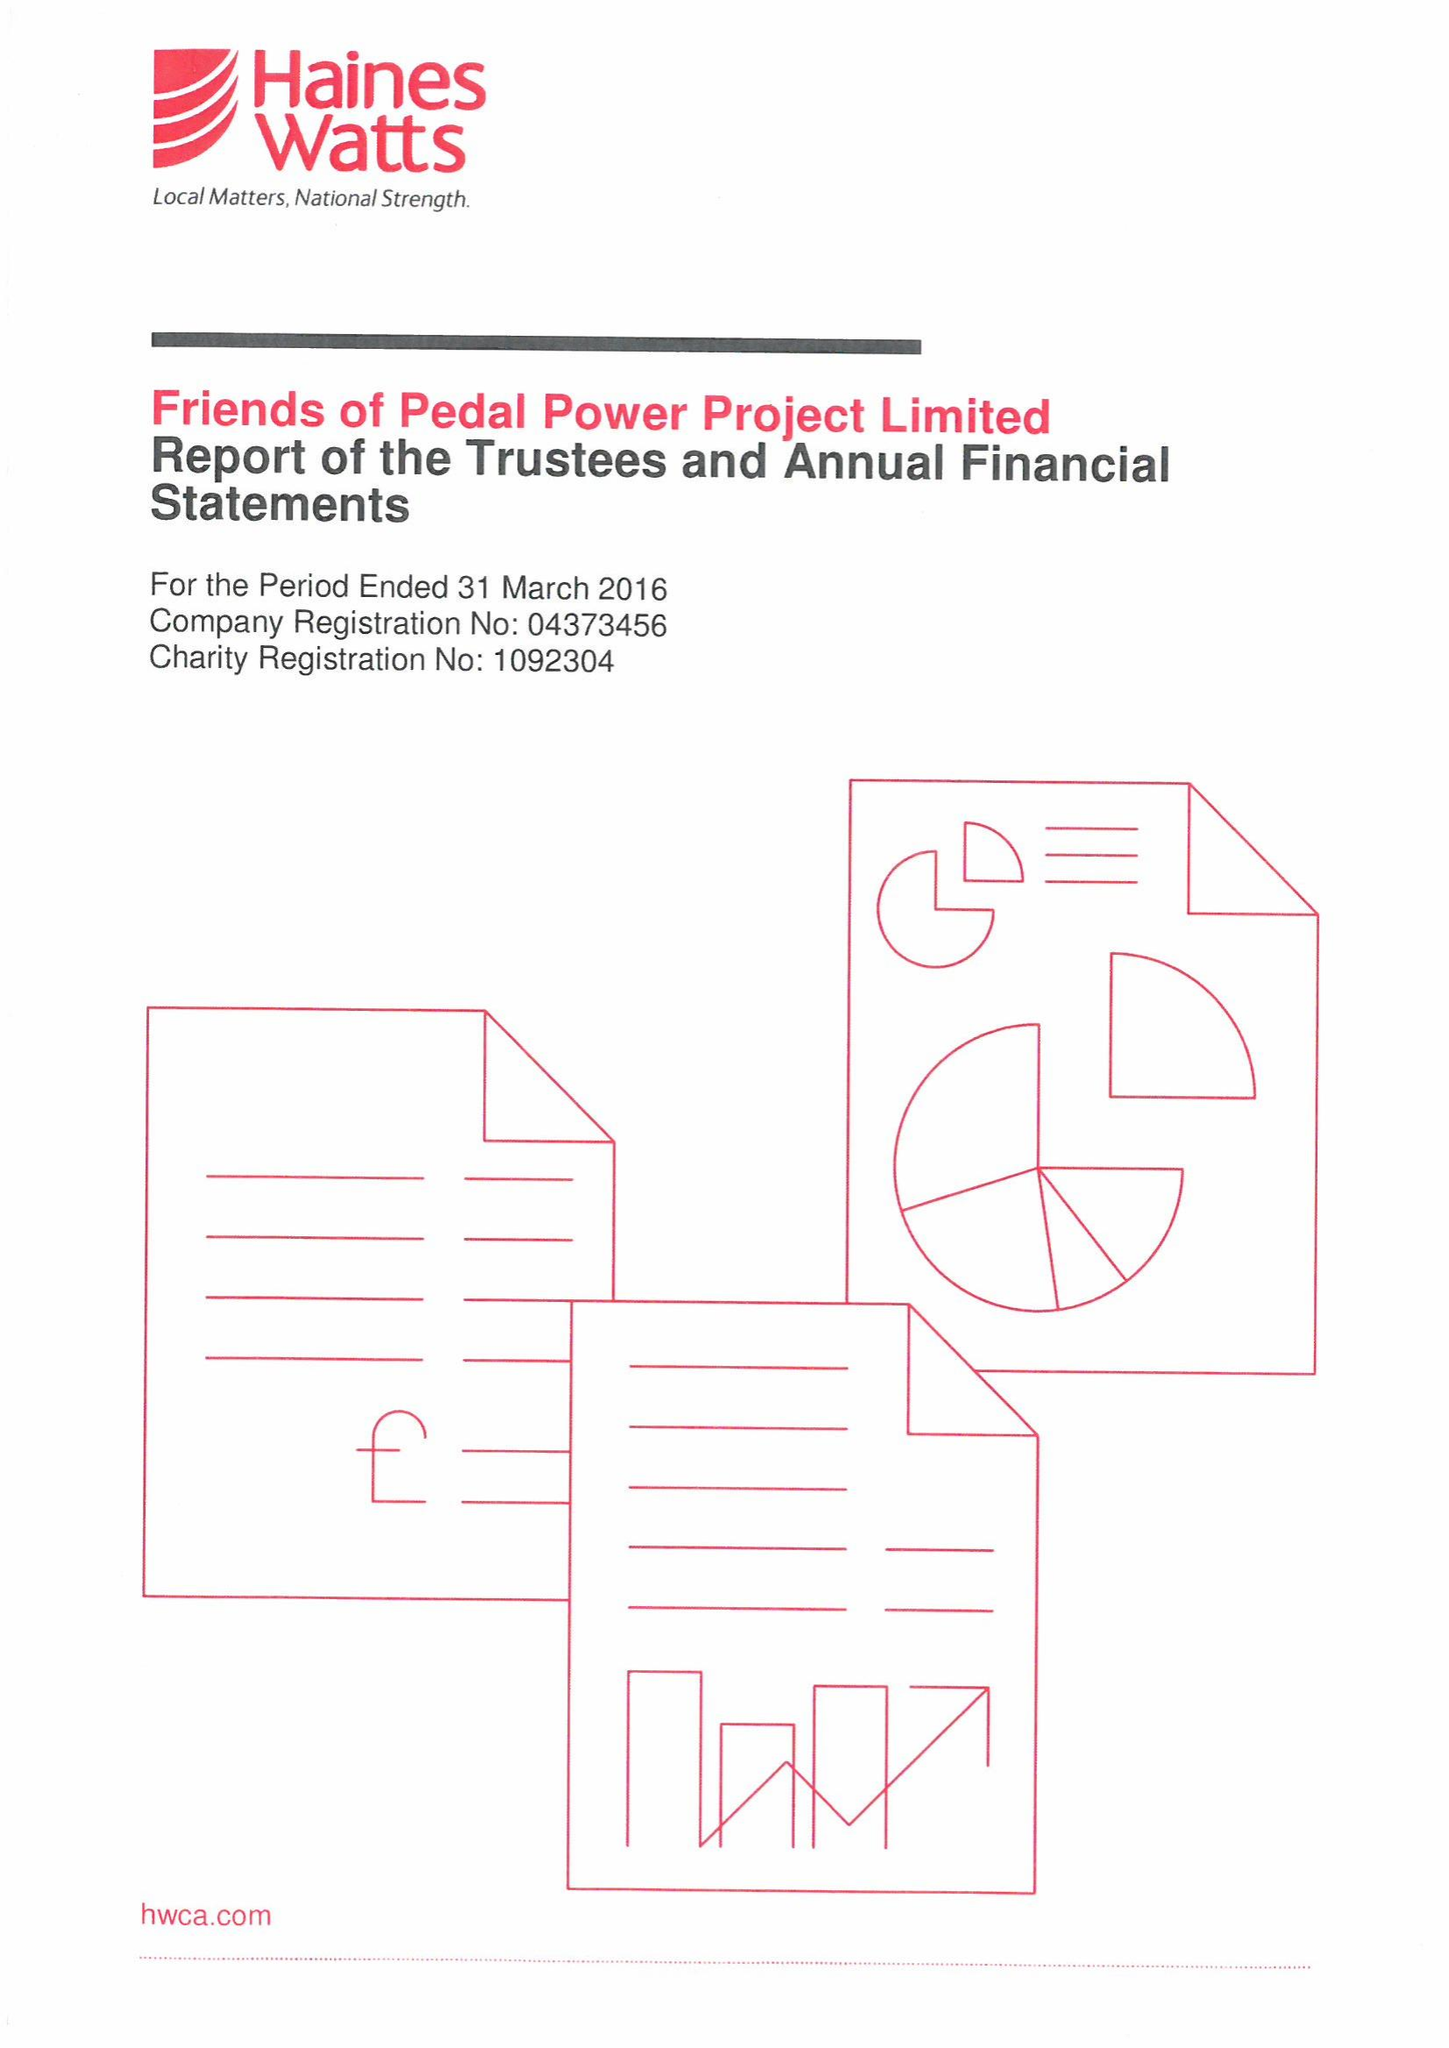What is the value for the address__postcode?
Answer the question using a single word or phrase. CF11 9JJ 